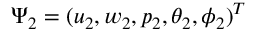Convert formula to latex. <formula><loc_0><loc_0><loc_500><loc_500>\Psi _ { 2 } = ( u _ { 2 } , w _ { 2 } , p _ { 2 } , \theta _ { 2 } , \phi _ { 2 } ) ^ { T }</formula> 